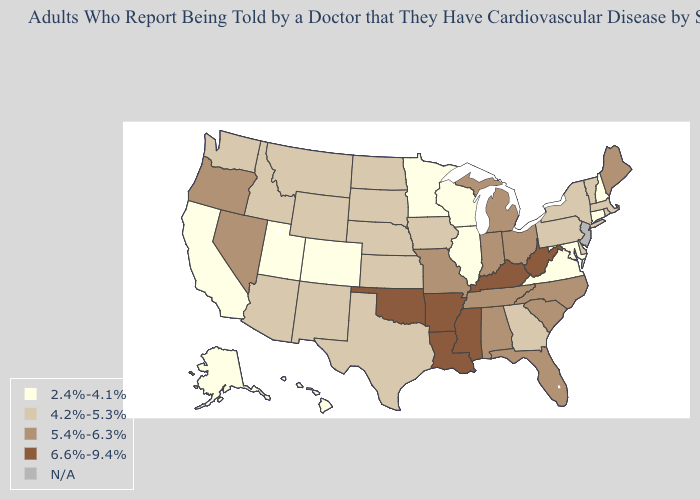Does Alabama have the highest value in the USA?
Keep it brief. No. What is the value of Kentucky?
Give a very brief answer. 6.6%-9.4%. What is the value of Utah?
Give a very brief answer. 2.4%-4.1%. Among the states that border Tennessee , does Virginia have the lowest value?
Give a very brief answer. Yes. What is the value of Ohio?
Short answer required. 5.4%-6.3%. Among the states that border Minnesota , does South Dakota have the highest value?
Answer briefly. Yes. What is the value of Vermont?
Give a very brief answer. 4.2%-5.3%. Name the states that have a value in the range 4.2%-5.3%?
Keep it brief. Arizona, Delaware, Georgia, Idaho, Iowa, Kansas, Massachusetts, Montana, Nebraska, New Mexico, New York, North Dakota, Pennsylvania, Rhode Island, South Dakota, Texas, Vermont, Washington, Wyoming. Name the states that have a value in the range 4.2%-5.3%?
Quick response, please. Arizona, Delaware, Georgia, Idaho, Iowa, Kansas, Massachusetts, Montana, Nebraska, New Mexico, New York, North Dakota, Pennsylvania, Rhode Island, South Dakota, Texas, Vermont, Washington, Wyoming. What is the lowest value in states that border Alabama?
Concise answer only. 4.2%-5.3%. Does South Dakota have the lowest value in the MidWest?
Answer briefly. No. Name the states that have a value in the range N/A?
Write a very short answer. New Jersey. Among the states that border Washington , does Idaho have the highest value?
Write a very short answer. No. What is the value of Illinois?
Short answer required. 2.4%-4.1%. 